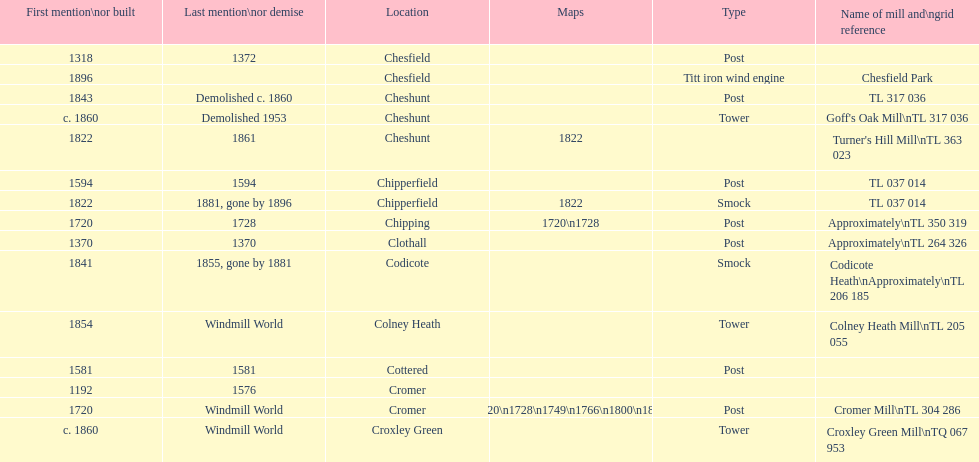What is the total number of mills named cheshunt? 3. 